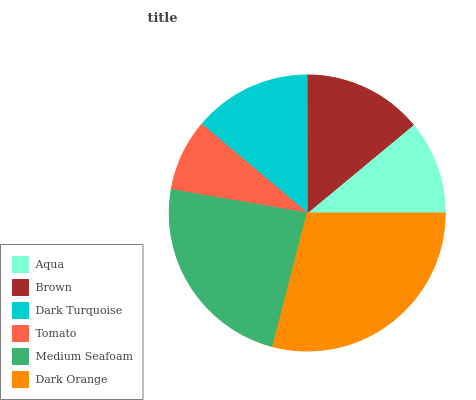Is Tomato the minimum?
Answer yes or no. Yes. Is Dark Orange the maximum?
Answer yes or no. Yes. Is Brown the minimum?
Answer yes or no. No. Is Brown the maximum?
Answer yes or no. No. Is Brown greater than Aqua?
Answer yes or no. Yes. Is Aqua less than Brown?
Answer yes or no. Yes. Is Aqua greater than Brown?
Answer yes or no. No. Is Brown less than Aqua?
Answer yes or no. No. Is Brown the high median?
Answer yes or no. Yes. Is Dark Turquoise the low median?
Answer yes or no. Yes. Is Medium Seafoam the high median?
Answer yes or no. No. Is Dark Orange the low median?
Answer yes or no. No. 